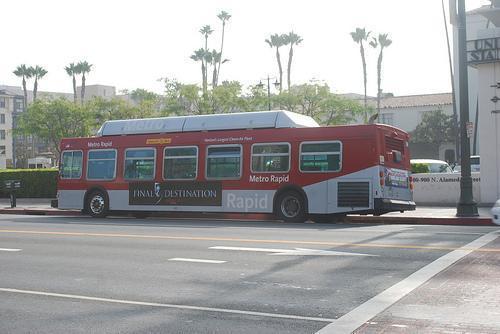How many buses are in the photo?
Give a very brief answer. 1. 